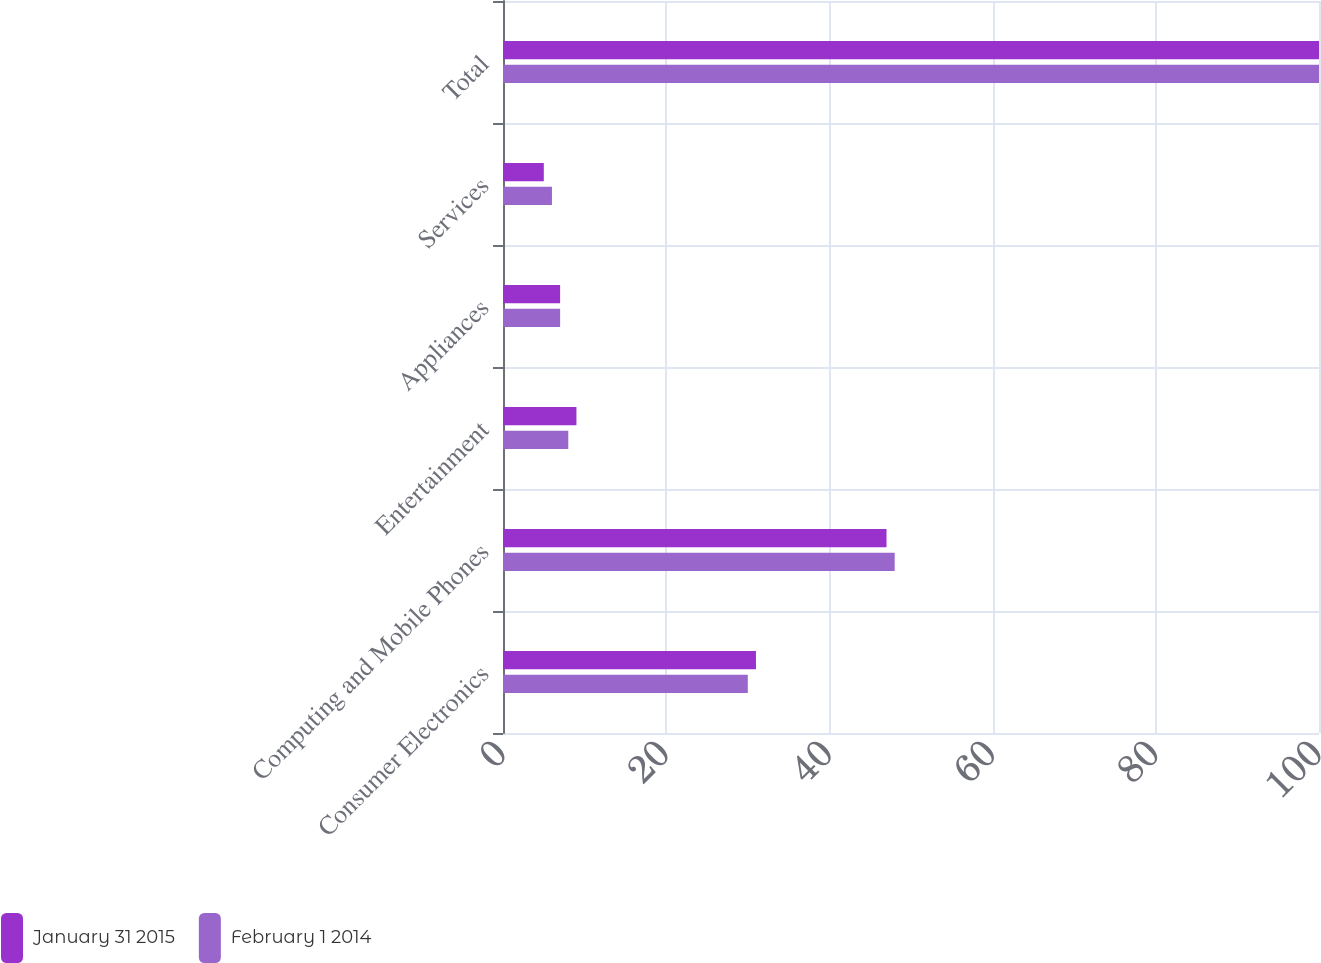Convert chart to OTSL. <chart><loc_0><loc_0><loc_500><loc_500><stacked_bar_chart><ecel><fcel>Consumer Electronics<fcel>Computing and Mobile Phones<fcel>Entertainment<fcel>Appliances<fcel>Services<fcel>Total<nl><fcel>January 31 2015<fcel>31<fcel>47<fcel>9<fcel>7<fcel>5<fcel>100<nl><fcel>February 1 2014<fcel>30<fcel>48<fcel>8<fcel>7<fcel>6<fcel>100<nl></chart> 